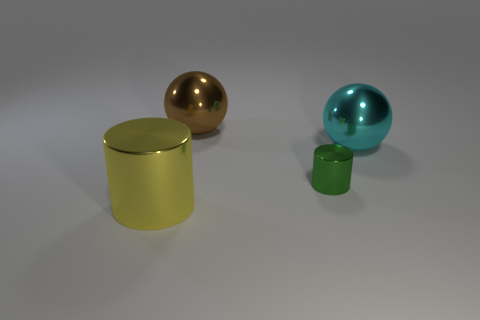Subtract all yellow cylinders. Subtract all gray blocks. How many cylinders are left? 1 Add 1 large cyan metallic spheres. How many objects exist? 5 Subtract 0 green balls. How many objects are left? 4 Subtract all cyan spheres. Subtract all large cyan balls. How many objects are left? 2 Add 2 green metallic cylinders. How many green metallic cylinders are left? 3 Add 3 large blue metallic things. How many large blue metallic things exist? 3 